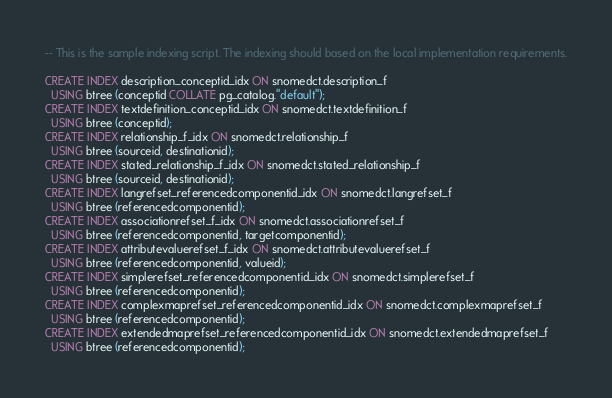<code> <loc_0><loc_0><loc_500><loc_500><_SQL_>-- This is the sample indexing script. The indexing should based on the local implementation requirements.

CREATE INDEX description_conceptid_idx ON snomedct.description_f
  USING btree (conceptid COLLATE pg_catalog."default");
CREATE INDEX textdefinition_conceptid_idx ON snomedct.textdefinition_f
  USING btree (conceptid);
CREATE INDEX relationship_f_idx ON snomedct.relationship_f
  USING btree (sourceid, destinationid);
CREATE INDEX stated_relationship_f_idx ON snomedct.stated_relationship_f
  USING btree (sourceid, destinationid);
CREATE INDEX langrefset_referencedcomponentid_idx ON snomedct.langrefset_f
  USING btree (referencedcomponentid);
CREATE INDEX associationrefset_f_idx ON snomedct.associationrefset_f
  USING btree (referencedcomponentid, targetcomponentid);
CREATE INDEX attributevaluerefset_f_idx ON snomedct.attributevaluerefset_f
  USING btree (referencedcomponentid, valueid);
CREATE INDEX simplerefset_referencedcomponentid_idx ON snomedct.simplerefset_f
  USING btree (referencedcomponentid);
CREATE INDEX complexmaprefset_referencedcomponentid_idx ON snomedct.complexmaprefset_f
  USING btree (referencedcomponentid);
CREATE INDEX extendedmaprefset_referencedcomponentid_idx ON snomedct.extendedmaprefset_f
  USING btree (referencedcomponentid);</code> 